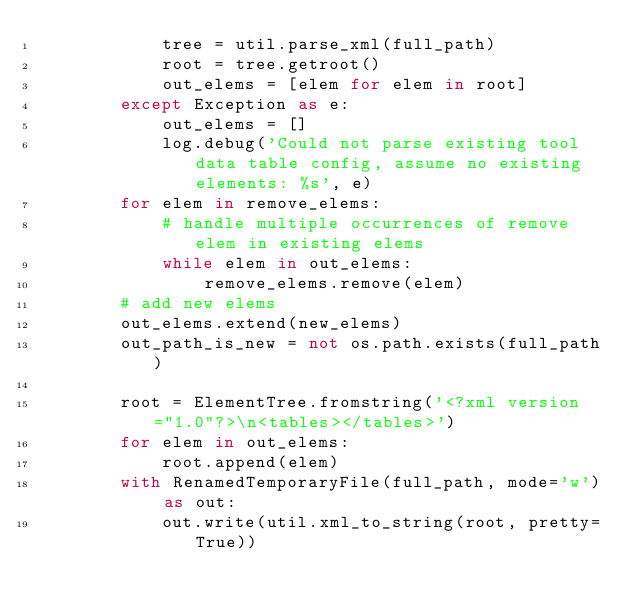Convert code to text. <code><loc_0><loc_0><loc_500><loc_500><_Python_>            tree = util.parse_xml(full_path)
            root = tree.getroot()
            out_elems = [elem for elem in root]
        except Exception as e:
            out_elems = []
            log.debug('Could not parse existing tool data table config, assume no existing elements: %s', e)
        for elem in remove_elems:
            # handle multiple occurrences of remove elem in existing elems
            while elem in out_elems:
                remove_elems.remove(elem)
        # add new elems
        out_elems.extend(new_elems)
        out_path_is_new = not os.path.exists(full_path)

        root = ElementTree.fromstring('<?xml version="1.0"?>\n<tables></tables>')
        for elem in out_elems:
            root.append(elem)
        with RenamedTemporaryFile(full_path, mode='w') as out:
            out.write(util.xml_to_string(root, pretty=True))</code> 